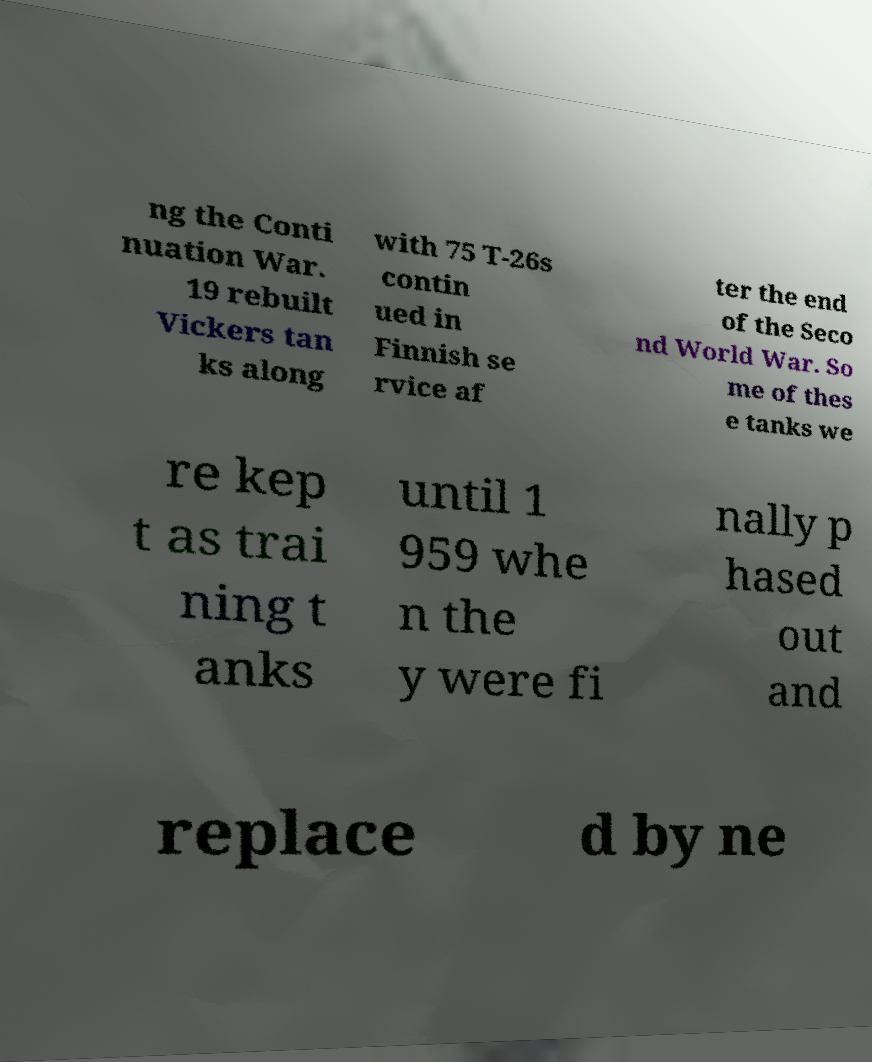Please read and relay the text visible in this image. What does it say? ng the Conti nuation War. 19 rebuilt Vickers tan ks along with 75 T-26s contin ued in Finnish se rvice af ter the end of the Seco nd World War. So me of thes e tanks we re kep t as trai ning t anks until 1 959 whe n the y were fi nally p hased out and replace d by ne 